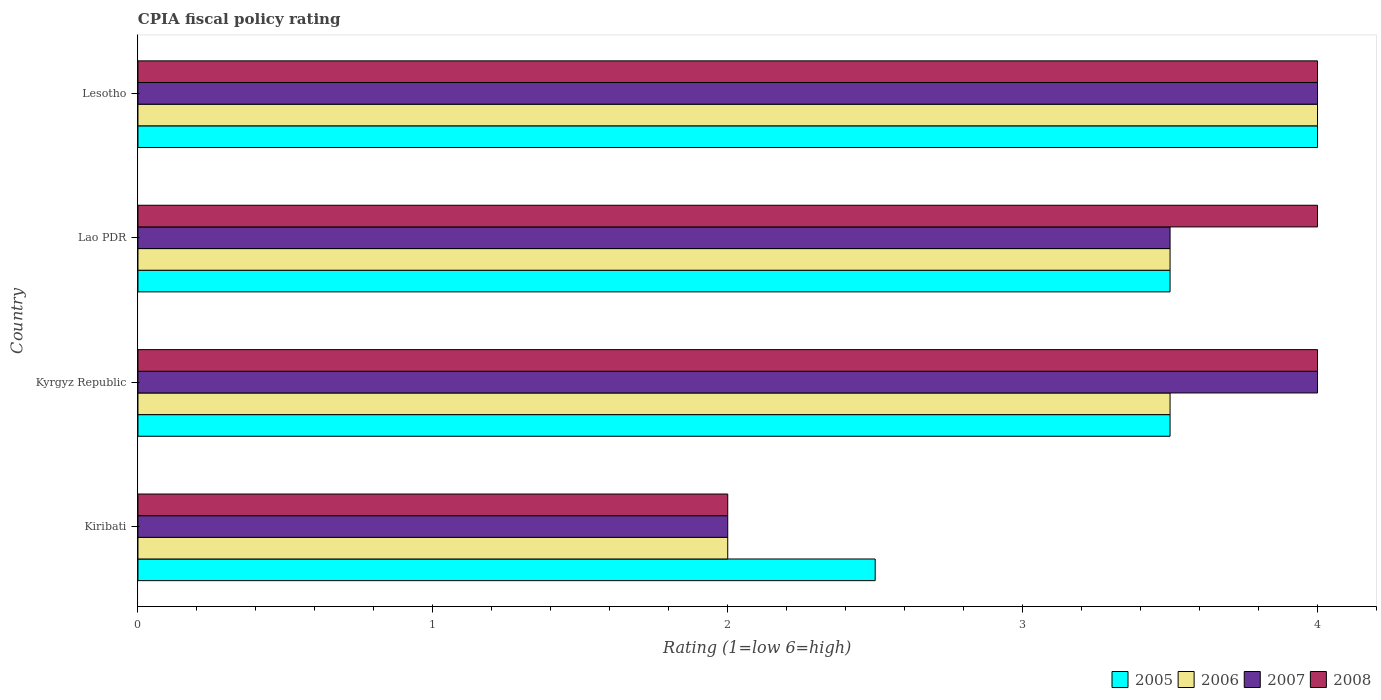How many groups of bars are there?
Your response must be concise. 4. Are the number of bars per tick equal to the number of legend labels?
Keep it short and to the point. Yes. Are the number of bars on each tick of the Y-axis equal?
Provide a succinct answer. Yes. How many bars are there on the 3rd tick from the bottom?
Your answer should be compact. 4. What is the label of the 3rd group of bars from the top?
Provide a succinct answer. Kyrgyz Republic. Across all countries, what is the maximum CPIA rating in 2007?
Your answer should be very brief. 4. Across all countries, what is the minimum CPIA rating in 2005?
Ensure brevity in your answer.  2.5. In which country was the CPIA rating in 2005 maximum?
Your response must be concise. Lesotho. In which country was the CPIA rating in 2005 minimum?
Offer a terse response. Kiribati. What is the total CPIA rating in 2005 in the graph?
Make the answer very short. 13.5. What is the difference between the CPIA rating in 2008 in Lao PDR and the CPIA rating in 2007 in Lesotho?
Give a very brief answer. 0. What is the average CPIA rating in 2007 per country?
Keep it short and to the point. 3.38. What is the difference between the CPIA rating in 2008 and CPIA rating in 2005 in Kiribati?
Your answer should be compact. -0.5. What is the ratio of the CPIA rating in 2008 in Kyrgyz Republic to that in Lao PDR?
Keep it short and to the point. 1. Is the difference between the CPIA rating in 2008 in Kiribati and Lao PDR greater than the difference between the CPIA rating in 2005 in Kiribati and Lao PDR?
Your answer should be compact. No. What is the difference between the highest and the second highest CPIA rating in 2008?
Offer a terse response. 0. What is the difference between the highest and the lowest CPIA rating in 2008?
Offer a terse response. 2. In how many countries, is the CPIA rating in 2008 greater than the average CPIA rating in 2008 taken over all countries?
Keep it short and to the point. 3. Is the sum of the CPIA rating in 2006 in Lao PDR and Lesotho greater than the maximum CPIA rating in 2008 across all countries?
Offer a very short reply. Yes. Are all the bars in the graph horizontal?
Offer a terse response. Yes. How many countries are there in the graph?
Provide a short and direct response. 4. Does the graph contain any zero values?
Your answer should be compact. No. Does the graph contain grids?
Provide a short and direct response. No. Where does the legend appear in the graph?
Your answer should be compact. Bottom right. How many legend labels are there?
Your answer should be very brief. 4. What is the title of the graph?
Provide a succinct answer. CPIA fiscal policy rating. Does "2011" appear as one of the legend labels in the graph?
Your answer should be very brief. No. What is the label or title of the X-axis?
Your answer should be very brief. Rating (1=low 6=high). What is the Rating (1=low 6=high) of 2005 in Kiribati?
Your answer should be very brief. 2.5. What is the Rating (1=low 6=high) of 2005 in Kyrgyz Republic?
Give a very brief answer. 3.5. What is the Rating (1=low 6=high) in 2006 in Kyrgyz Republic?
Give a very brief answer. 3.5. What is the Rating (1=low 6=high) in 2005 in Lao PDR?
Offer a terse response. 3.5. What is the Rating (1=low 6=high) in 2007 in Lao PDR?
Offer a very short reply. 3.5. What is the Rating (1=low 6=high) of 2007 in Lesotho?
Offer a terse response. 4. Across all countries, what is the maximum Rating (1=low 6=high) in 2005?
Your response must be concise. 4. Across all countries, what is the maximum Rating (1=low 6=high) of 2007?
Your answer should be compact. 4. Across all countries, what is the maximum Rating (1=low 6=high) in 2008?
Offer a terse response. 4. Across all countries, what is the minimum Rating (1=low 6=high) of 2006?
Provide a short and direct response. 2. Across all countries, what is the minimum Rating (1=low 6=high) in 2007?
Ensure brevity in your answer.  2. Across all countries, what is the minimum Rating (1=low 6=high) in 2008?
Give a very brief answer. 2. What is the total Rating (1=low 6=high) in 2005 in the graph?
Ensure brevity in your answer.  13.5. What is the difference between the Rating (1=low 6=high) of 2006 in Kiribati and that in Kyrgyz Republic?
Provide a short and direct response. -1.5. What is the difference between the Rating (1=low 6=high) in 2006 in Kiribati and that in Lao PDR?
Your response must be concise. -1.5. What is the difference between the Rating (1=low 6=high) of 2007 in Kiribati and that in Lao PDR?
Your answer should be compact. -1.5. What is the difference between the Rating (1=low 6=high) in 2008 in Kiribati and that in Lao PDR?
Give a very brief answer. -2. What is the difference between the Rating (1=low 6=high) of 2006 in Kiribati and that in Lesotho?
Offer a very short reply. -2. What is the difference between the Rating (1=low 6=high) of 2007 in Kiribati and that in Lesotho?
Make the answer very short. -2. What is the difference between the Rating (1=low 6=high) in 2007 in Kyrgyz Republic and that in Lao PDR?
Provide a short and direct response. 0.5. What is the difference between the Rating (1=low 6=high) of 2008 in Kyrgyz Republic and that in Lao PDR?
Your answer should be compact. 0. What is the difference between the Rating (1=low 6=high) in 2005 in Kyrgyz Republic and that in Lesotho?
Offer a terse response. -0.5. What is the difference between the Rating (1=low 6=high) in 2007 in Kyrgyz Republic and that in Lesotho?
Make the answer very short. 0. What is the difference between the Rating (1=low 6=high) in 2008 in Kyrgyz Republic and that in Lesotho?
Your answer should be compact. 0. What is the difference between the Rating (1=low 6=high) of 2006 in Lao PDR and that in Lesotho?
Provide a short and direct response. -0.5. What is the difference between the Rating (1=low 6=high) of 2007 in Lao PDR and that in Lesotho?
Provide a succinct answer. -0.5. What is the difference between the Rating (1=low 6=high) of 2008 in Lao PDR and that in Lesotho?
Provide a short and direct response. 0. What is the difference between the Rating (1=low 6=high) in 2005 in Kiribati and the Rating (1=low 6=high) in 2008 in Kyrgyz Republic?
Your answer should be very brief. -1.5. What is the difference between the Rating (1=low 6=high) of 2006 in Kiribati and the Rating (1=low 6=high) of 2007 in Kyrgyz Republic?
Give a very brief answer. -2. What is the difference between the Rating (1=low 6=high) of 2005 in Kiribati and the Rating (1=low 6=high) of 2006 in Lao PDR?
Provide a short and direct response. -1. What is the difference between the Rating (1=low 6=high) in 2007 in Kiribati and the Rating (1=low 6=high) in 2008 in Lao PDR?
Make the answer very short. -2. What is the difference between the Rating (1=low 6=high) of 2005 in Kiribati and the Rating (1=low 6=high) of 2006 in Lesotho?
Keep it short and to the point. -1.5. What is the difference between the Rating (1=low 6=high) in 2005 in Kiribati and the Rating (1=low 6=high) in 2008 in Lesotho?
Ensure brevity in your answer.  -1.5. What is the difference between the Rating (1=low 6=high) in 2006 in Kiribati and the Rating (1=low 6=high) in 2007 in Lesotho?
Your answer should be very brief. -2. What is the difference between the Rating (1=low 6=high) of 2006 in Kiribati and the Rating (1=low 6=high) of 2008 in Lesotho?
Keep it short and to the point. -2. What is the difference between the Rating (1=low 6=high) in 2007 in Kiribati and the Rating (1=low 6=high) in 2008 in Lesotho?
Keep it short and to the point. -2. What is the difference between the Rating (1=low 6=high) of 2005 in Kyrgyz Republic and the Rating (1=low 6=high) of 2007 in Lao PDR?
Offer a terse response. 0. What is the difference between the Rating (1=low 6=high) in 2007 in Kyrgyz Republic and the Rating (1=low 6=high) in 2008 in Lao PDR?
Make the answer very short. 0. What is the difference between the Rating (1=low 6=high) in 2005 in Kyrgyz Republic and the Rating (1=low 6=high) in 2006 in Lesotho?
Provide a succinct answer. -0.5. What is the difference between the Rating (1=low 6=high) in 2005 in Kyrgyz Republic and the Rating (1=low 6=high) in 2007 in Lesotho?
Your answer should be compact. -0.5. What is the difference between the Rating (1=low 6=high) of 2005 in Kyrgyz Republic and the Rating (1=low 6=high) of 2008 in Lesotho?
Give a very brief answer. -0.5. What is the difference between the Rating (1=low 6=high) in 2007 in Kyrgyz Republic and the Rating (1=low 6=high) in 2008 in Lesotho?
Provide a short and direct response. 0. What is the difference between the Rating (1=low 6=high) in 2005 in Lao PDR and the Rating (1=low 6=high) in 2006 in Lesotho?
Keep it short and to the point. -0.5. What is the difference between the Rating (1=low 6=high) of 2006 in Lao PDR and the Rating (1=low 6=high) of 2007 in Lesotho?
Give a very brief answer. -0.5. What is the average Rating (1=low 6=high) of 2005 per country?
Make the answer very short. 3.38. What is the average Rating (1=low 6=high) in 2007 per country?
Provide a short and direct response. 3.38. What is the difference between the Rating (1=low 6=high) in 2005 and Rating (1=low 6=high) in 2006 in Kiribati?
Provide a short and direct response. 0.5. What is the difference between the Rating (1=low 6=high) of 2005 and Rating (1=low 6=high) of 2007 in Kiribati?
Make the answer very short. 0.5. What is the difference between the Rating (1=low 6=high) in 2005 and Rating (1=low 6=high) in 2008 in Kiribati?
Ensure brevity in your answer.  0.5. What is the difference between the Rating (1=low 6=high) of 2006 and Rating (1=low 6=high) of 2007 in Kiribati?
Give a very brief answer. 0. What is the difference between the Rating (1=low 6=high) in 2006 and Rating (1=low 6=high) in 2008 in Kiribati?
Ensure brevity in your answer.  0. What is the difference between the Rating (1=low 6=high) of 2005 and Rating (1=low 6=high) of 2007 in Kyrgyz Republic?
Your answer should be very brief. -0.5. What is the difference between the Rating (1=low 6=high) in 2006 and Rating (1=low 6=high) in 2007 in Kyrgyz Republic?
Make the answer very short. -0.5. What is the difference between the Rating (1=low 6=high) of 2005 and Rating (1=low 6=high) of 2006 in Lao PDR?
Your response must be concise. 0. What is the difference between the Rating (1=low 6=high) of 2005 and Rating (1=low 6=high) of 2007 in Lao PDR?
Make the answer very short. 0. What is the difference between the Rating (1=low 6=high) in 2006 and Rating (1=low 6=high) in 2007 in Lao PDR?
Your response must be concise. 0. What is the difference between the Rating (1=low 6=high) in 2006 and Rating (1=low 6=high) in 2008 in Lao PDR?
Your response must be concise. -0.5. What is the difference between the Rating (1=low 6=high) of 2007 and Rating (1=low 6=high) of 2008 in Lao PDR?
Your answer should be compact. -0.5. What is the difference between the Rating (1=low 6=high) of 2005 and Rating (1=low 6=high) of 2007 in Lesotho?
Offer a terse response. 0. What is the ratio of the Rating (1=low 6=high) in 2005 in Kiribati to that in Kyrgyz Republic?
Make the answer very short. 0.71. What is the ratio of the Rating (1=low 6=high) of 2006 in Kiribati to that in Kyrgyz Republic?
Offer a terse response. 0.57. What is the ratio of the Rating (1=low 6=high) in 2008 in Kiribati to that in Kyrgyz Republic?
Ensure brevity in your answer.  0.5. What is the ratio of the Rating (1=low 6=high) in 2005 in Kiribati to that in Lao PDR?
Provide a short and direct response. 0.71. What is the ratio of the Rating (1=low 6=high) in 2007 in Kiribati to that in Lao PDR?
Make the answer very short. 0.57. What is the ratio of the Rating (1=low 6=high) of 2008 in Kiribati to that in Lao PDR?
Make the answer very short. 0.5. What is the ratio of the Rating (1=low 6=high) in 2006 in Kiribati to that in Lesotho?
Your response must be concise. 0.5. What is the ratio of the Rating (1=low 6=high) of 2008 in Kiribati to that in Lesotho?
Keep it short and to the point. 0.5. What is the ratio of the Rating (1=low 6=high) in 2005 in Kyrgyz Republic to that in Lao PDR?
Give a very brief answer. 1. What is the ratio of the Rating (1=low 6=high) of 2006 in Kyrgyz Republic to that in Lao PDR?
Offer a very short reply. 1. What is the ratio of the Rating (1=low 6=high) of 2007 in Kyrgyz Republic to that in Lao PDR?
Provide a short and direct response. 1.14. What is the ratio of the Rating (1=low 6=high) in 2008 in Kyrgyz Republic to that in Lao PDR?
Your answer should be compact. 1. What is the ratio of the Rating (1=low 6=high) in 2005 in Kyrgyz Republic to that in Lesotho?
Offer a very short reply. 0.88. What is the ratio of the Rating (1=low 6=high) of 2006 in Kyrgyz Republic to that in Lesotho?
Your answer should be very brief. 0.88. What is the ratio of the Rating (1=low 6=high) of 2008 in Kyrgyz Republic to that in Lesotho?
Provide a succinct answer. 1. What is the difference between the highest and the second highest Rating (1=low 6=high) in 2005?
Your answer should be very brief. 0.5. What is the difference between the highest and the second highest Rating (1=low 6=high) in 2006?
Your response must be concise. 0.5. What is the difference between the highest and the lowest Rating (1=low 6=high) of 2006?
Make the answer very short. 2. What is the difference between the highest and the lowest Rating (1=low 6=high) of 2007?
Offer a terse response. 2. What is the difference between the highest and the lowest Rating (1=low 6=high) of 2008?
Ensure brevity in your answer.  2. 